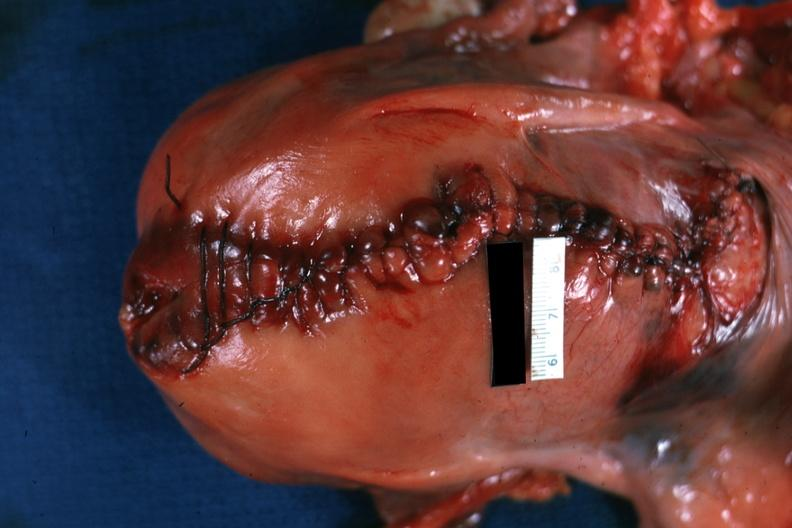s uterus present?
Answer the question using a single word or phrase. Yes 